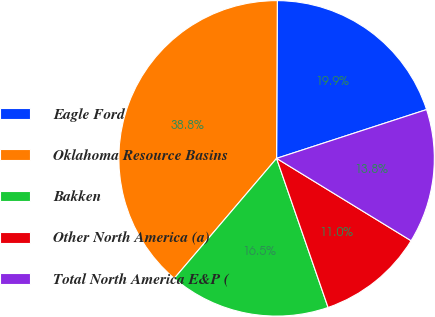Convert chart. <chart><loc_0><loc_0><loc_500><loc_500><pie_chart><fcel>Eagle Ford<fcel>Oklahoma Resource Basins<fcel>Bakken<fcel>Other North America (a)<fcel>Total North America E&P (<nl><fcel>19.92%<fcel>38.84%<fcel>16.53%<fcel>10.96%<fcel>13.75%<nl></chart> 